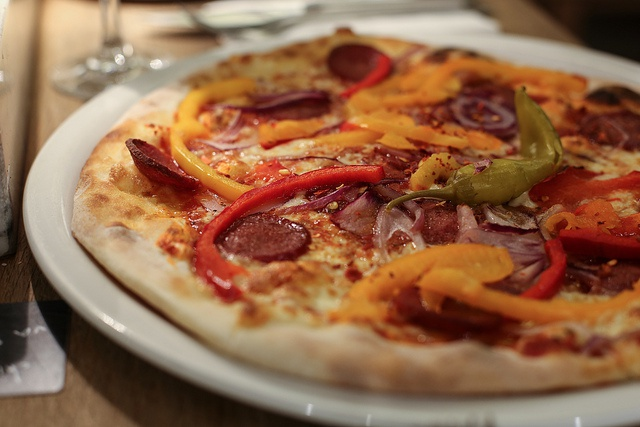Describe the objects in this image and their specific colors. I can see pizza in ivory, brown, maroon, and gray tones and wine glass in ivory, tan, and gray tones in this image. 